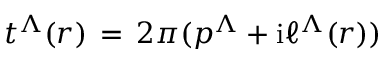<formula> <loc_0><loc_0><loc_500><loc_500>t ^ { \Lambda } ( r ) \, = \, 2 \pi ( p ^ { \Lambda } + i \ell ^ { \Lambda } ( r ) ) \,</formula> 